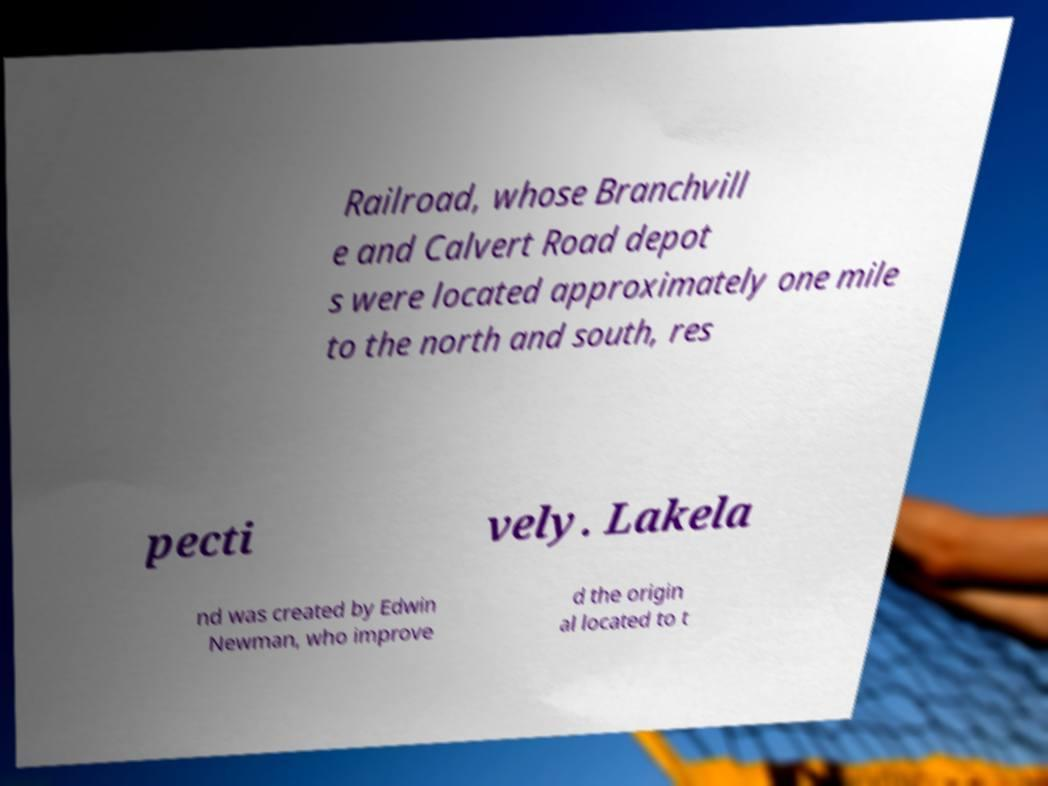What messages or text are displayed in this image? I need them in a readable, typed format. Railroad, whose Branchvill e and Calvert Road depot s were located approximately one mile to the north and south, res pecti vely. Lakela nd was created by Edwin Newman, who improve d the origin al located to t 